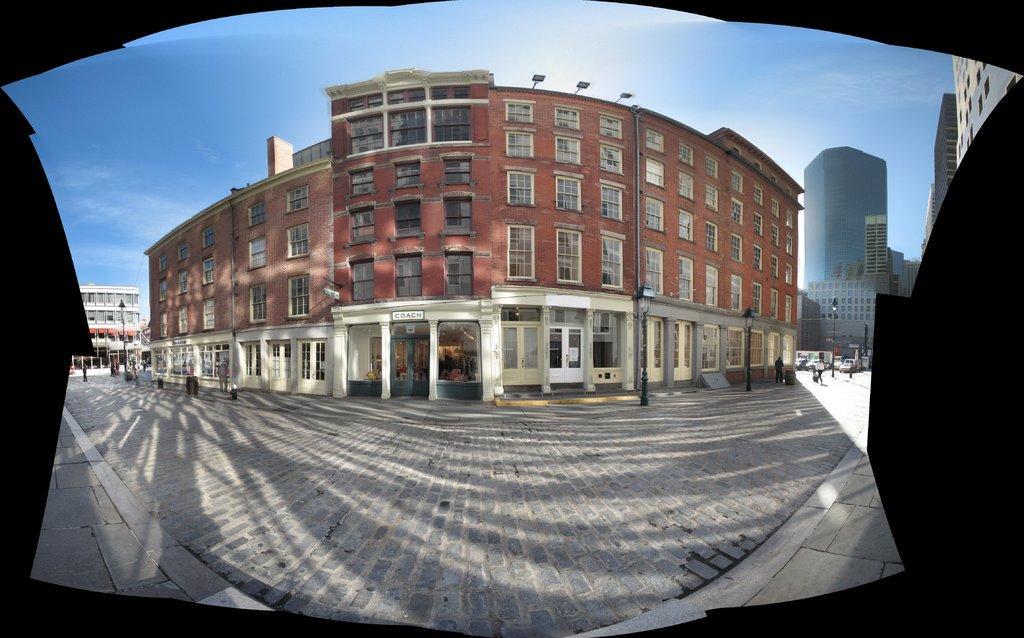Could you give a brief overview of what you see in this image? In this picture we can see buildings, poles, boards, and few people. In the background there is sky. 